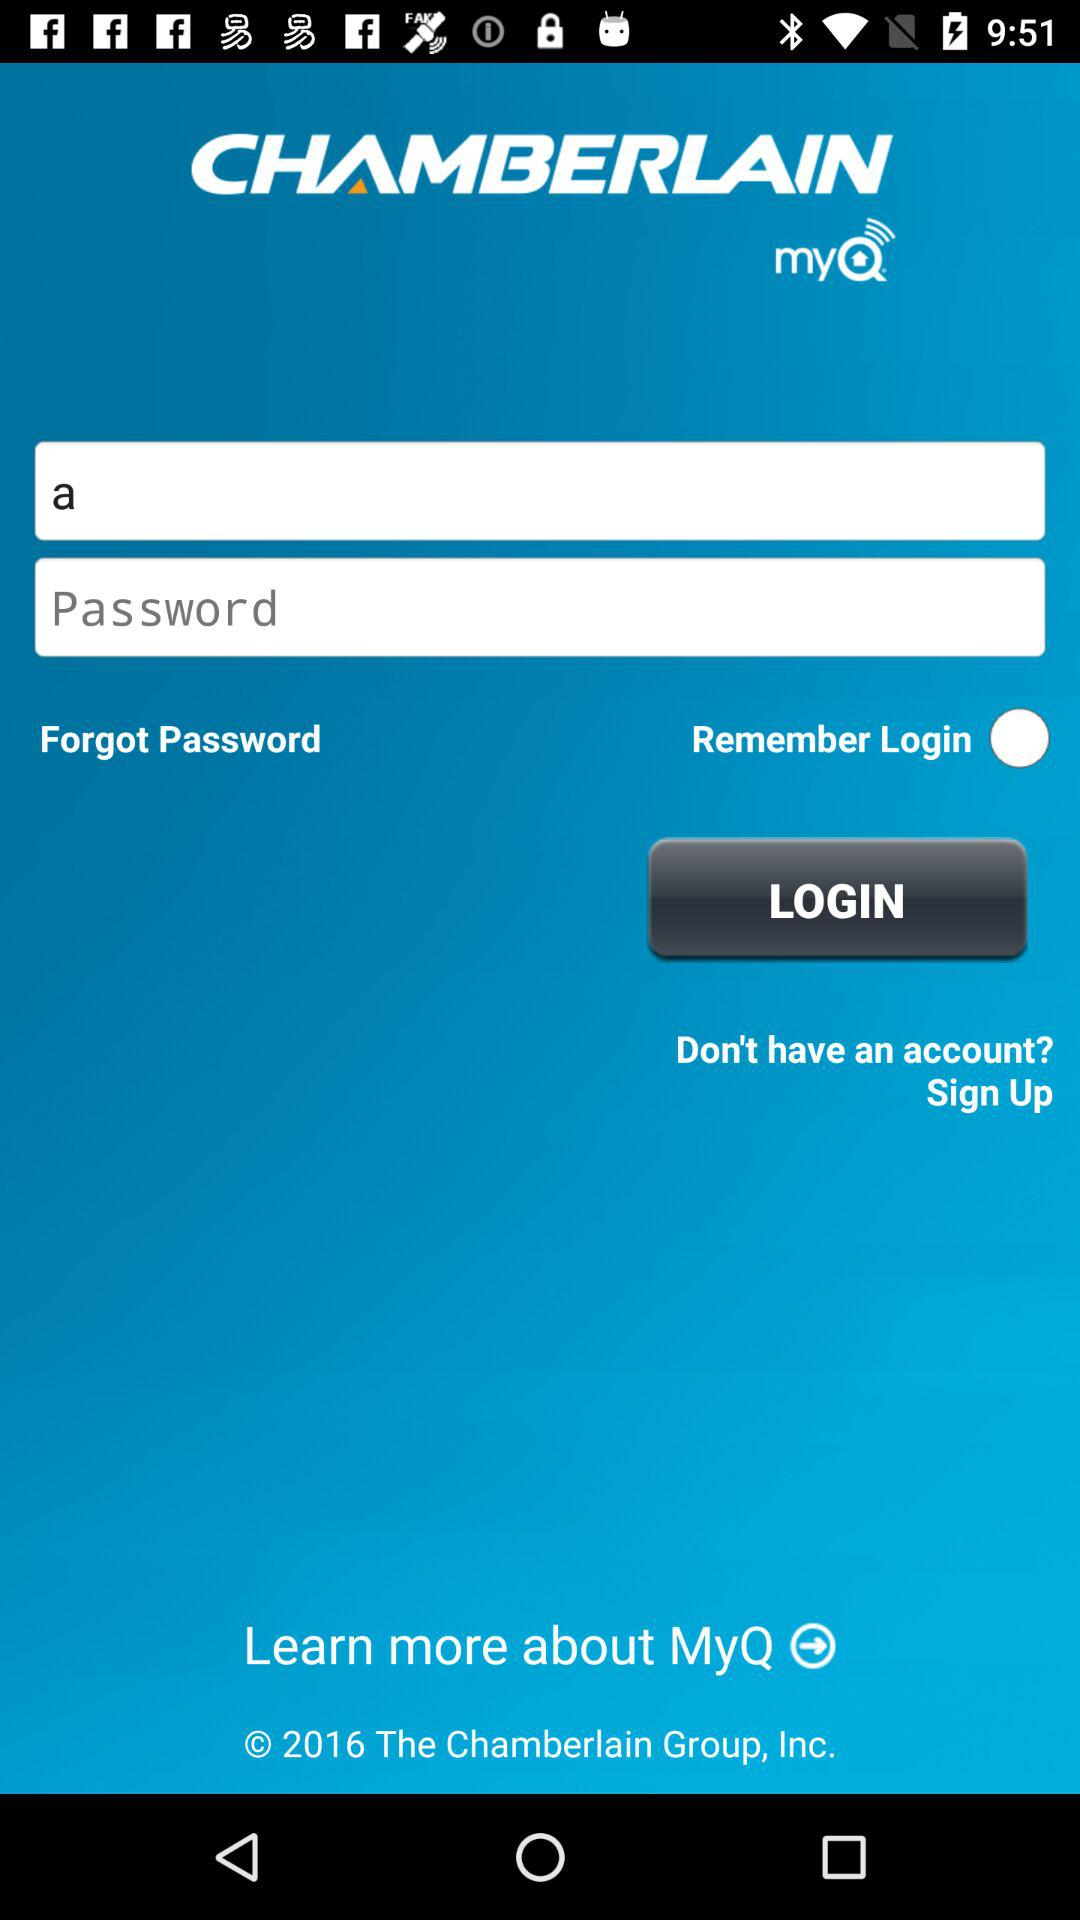How many text inputs are in the login form?
Answer the question using a single word or phrase. 2 